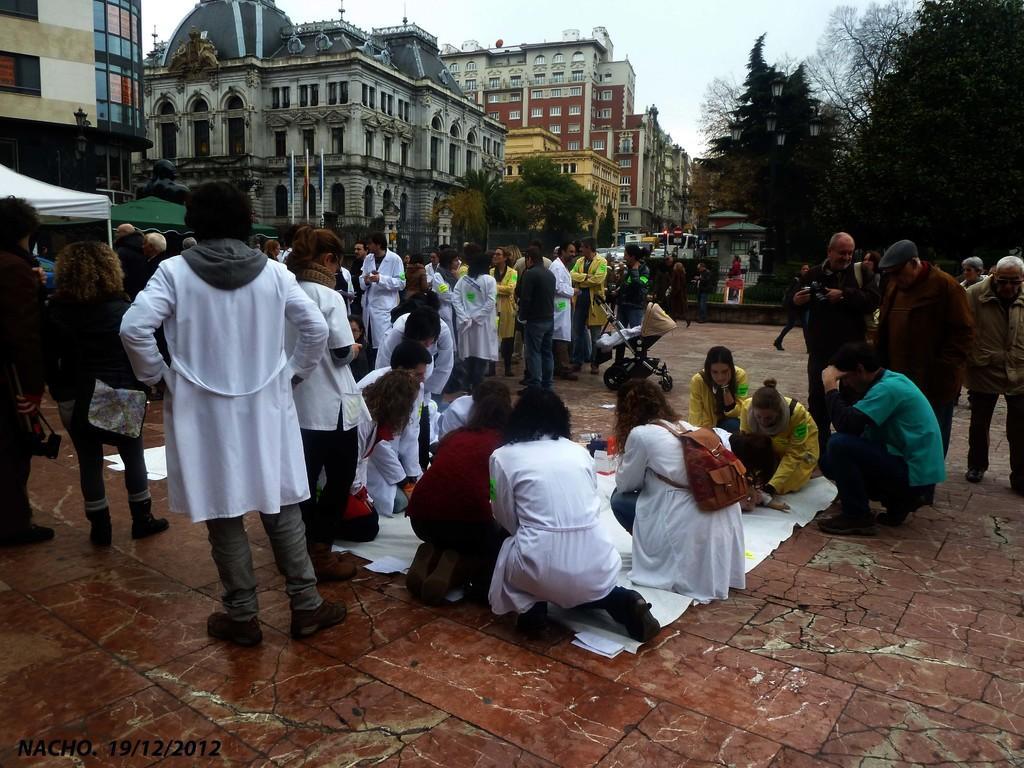In one or two sentences, can you explain what this image depicts? There are group of people sitting in squat position. This looks like a stroller. I can see groups of people standing. These are the buildings with the windows. I can see the trees. This looks like a white cloth, which is placed on the floor. At the bottom of the image, I can see the watermark. 